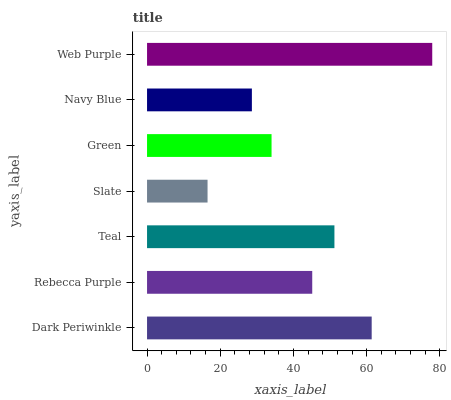Is Slate the minimum?
Answer yes or no. Yes. Is Web Purple the maximum?
Answer yes or no. Yes. Is Rebecca Purple the minimum?
Answer yes or no. No. Is Rebecca Purple the maximum?
Answer yes or no. No. Is Dark Periwinkle greater than Rebecca Purple?
Answer yes or no. Yes. Is Rebecca Purple less than Dark Periwinkle?
Answer yes or no. Yes. Is Rebecca Purple greater than Dark Periwinkle?
Answer yes or no. No. Is Dark Periwinkle less than Rebecca Purple?
Answer yes or no. No. Is Rebecca Purple the high median?
Answer yes or no. Yes. Is Rebecca Purple the low median?
Answer yes or no. Yes. Is Dark Periwinkle the high median?
Answer yes or no. No. Is Slate the low median?
Answer yes or no. No. 